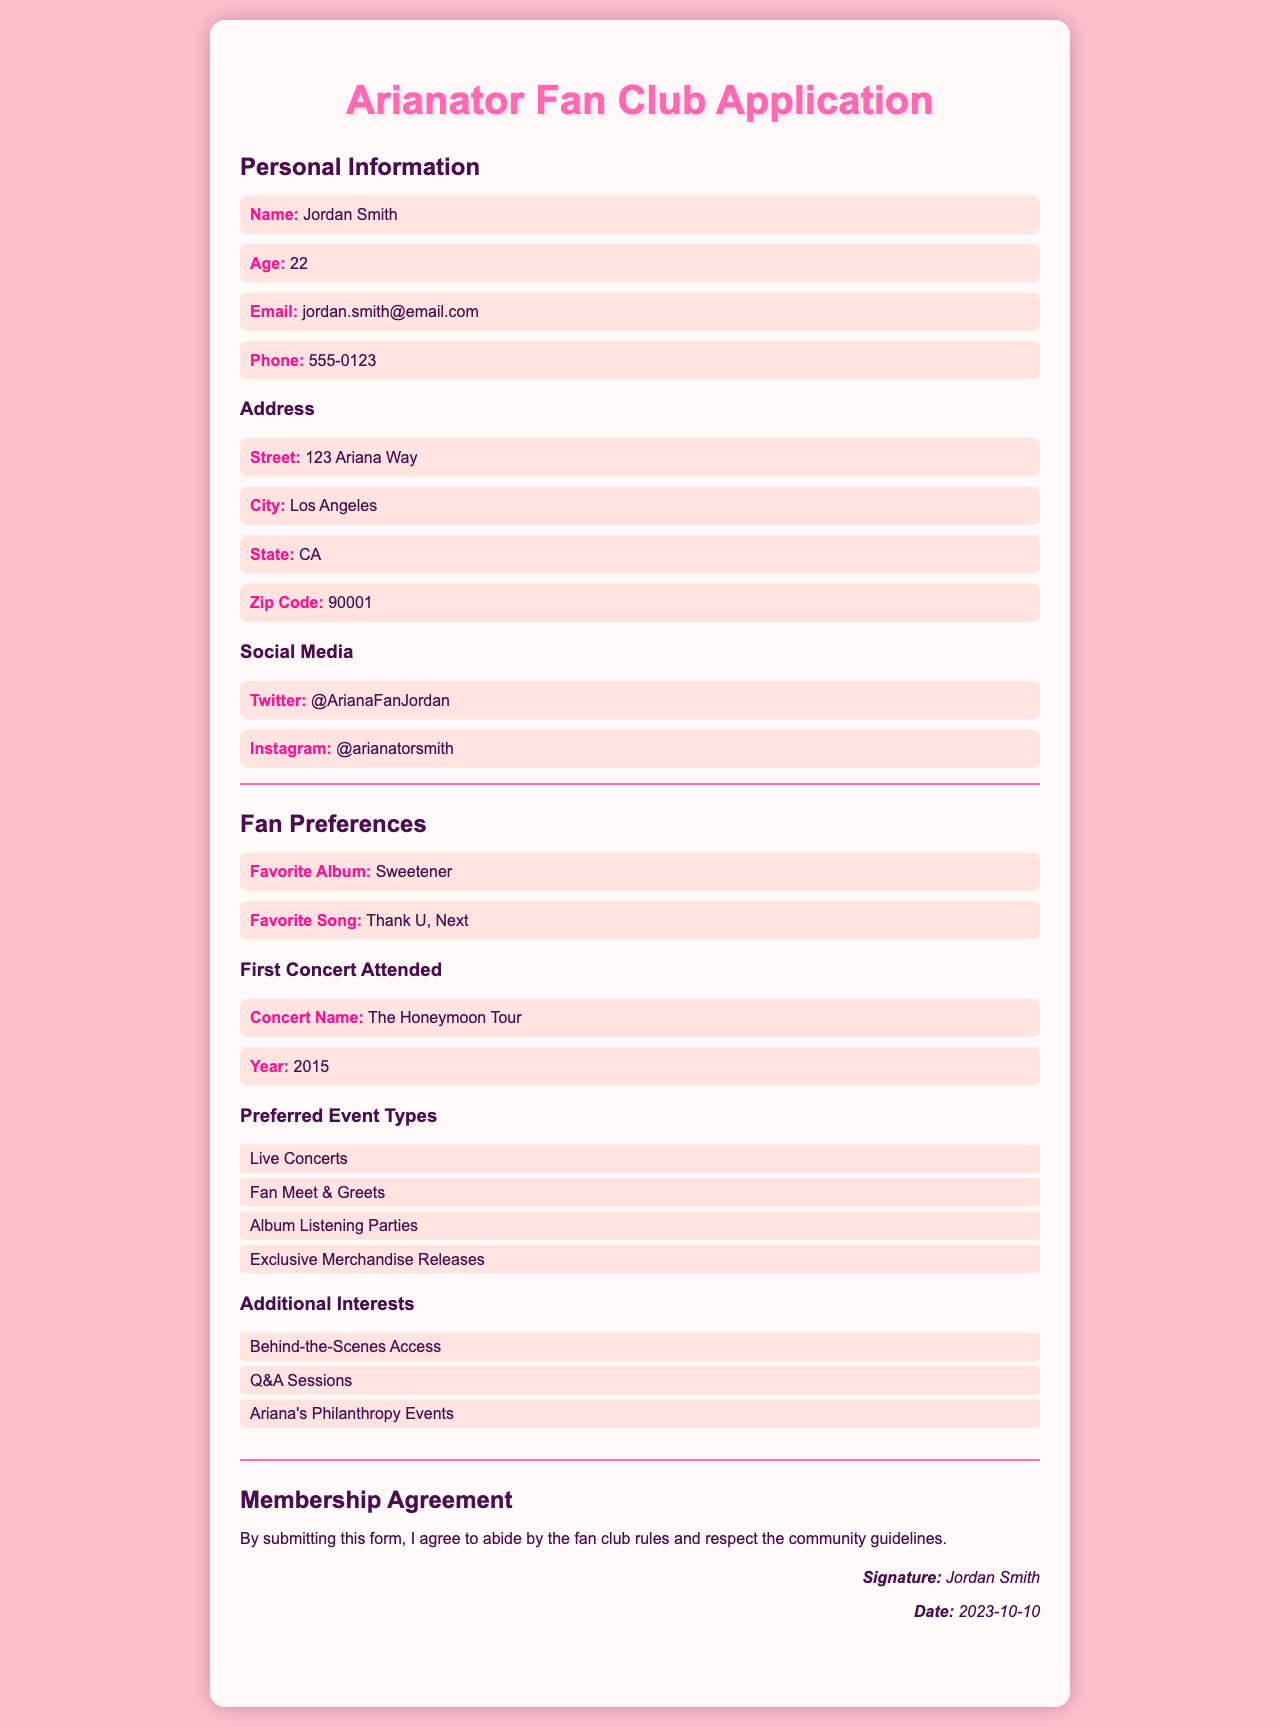What is the applicant's name? The name of the applicant is mentioned under Personal Information.
Answer: Jordan Smith What is the applicant's age? The age of the applicant can be found in the same section as the name.
Answer: 22 What is the applicant's email address? The email address is part of the personal information section.
Answer: jordan.smith@email.com What is the favorite album listed by the applicant? The favorite album is specified under Fan Preferences.
Answer: Sweetener What year did the applicant attend their first concert? The year of the first concert attended is provided under the First Concert Attended section.
Answer: 2015 What type of events does the applicant prefer? Information about preferred event types is provided in a list format under Fan Preferences.
Answer: Live Concerts, Fan Meet & Greets, Album Listening Parties, Exclusive Merchandise Releases What does the applicant agree to by submitting the form? The membership agreement section states what the applicant agrees to upon form submission.
Answer: Abide by the fan club rules and respect the community guidelines What signature is provided in the membership agreement? The name of the signatory is located at the end of the Membership Agreement section.
Answer: Jordan Smith 